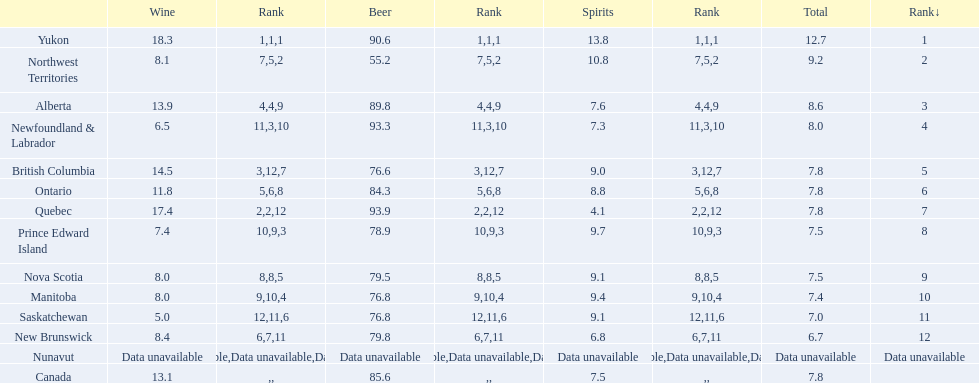0? 5. 